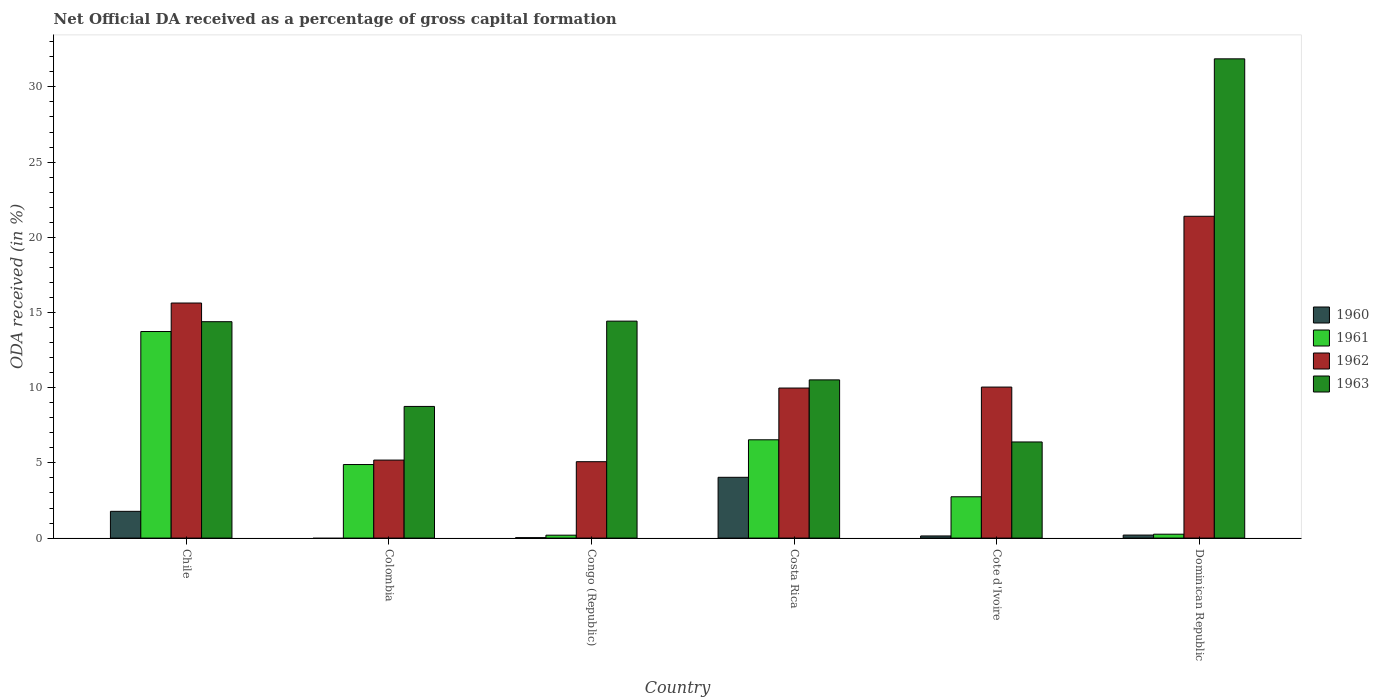How many different coloured bars are there?
Offer a terse response. 4. Are the number of bars on each tick of the X-axis equal?
Offer a terse response. No. What is the label of the 6th group of bars from the left?
Provide a succinct answer. Dominican Republic. In how many cases, is the number of bars for a given country not equal to the number of legend labels?
Give a very brief answer. 1. What is the net ODA received in 1960 in Dominican Republic?
Your answer should be very brief. 0.2. Across all countries, what is the maximum net ODA received in 1960?
Offer a terse response. 4.04. Across all countries, what is the minimum net ODA received in 1960?
Make the answer very short. 0. In which country was the net ODA received in 1961 maximum?
Your response must be concise. Chile. What is the total net ODA received in 1962 in the graph?
Provide a short and direct response. 67.31. What is the difference between the net ODA received in 1960 in Congo (Republic) and that in Dominican Republic?
Offer a very short reply. -0.17. What is the difference between the net ODA received in 1963 in Chile and the net ODA received in 1960 in Costa Rica?
Provide a short and direct response. 10.35. What is the average net ODA received in 1963 per country?
Offer a very short reply. 14.39. What is the difference between the net ODA received of/in 1961 and net ODA received of/in 1960 in Congo (Republic)?
Provide a succinct answer. 0.17. What is the ratio of the net ODA received in 1961 in Costa Rica to that in Cote d'Ivoire?
Give a very brief answer. 2.38. Is the difference between the net ODA received in 1961 in Chile and Cote d'Ivoire greater than the difference between the net ODA received in 1960 in Chile and Cote d'Ivoire?
Your response must be concise. Yes. What is the difference between the highest and the second highest net ODA received in 1962?
Offer a terse response. -11.35. What is the difference between the highest and the lowest net ODA received in 1962?
Your answer should be compact. 16.32. Is it the case that in every country, the sum of the net ODA received in 1963 and net ODA received in 1962 is greater than the sum of net ODA received in 1961 and net ODA received in 1960?
Offer a terse response. Yes. How many bars are there?
Offer a very short reply. 23. What is the difference between two consecutive major ticks on the Y-axis?
Offer a very short reply. 5. Are the values on the major ticks of Y-axis written in scientific E-notation?
Give a very brief answer. No. How many legend labels are there?
Your answer should be very brief. 4. How are the legend labels stacked?
Provide a succinct answer. Vertical. What is the title of the graph?
Your response must be concise. Net Official DA received as a percentage of gross capital formation. Does "1986" appear as one of the legend labels in the graph?
Provide a succinct answer. No. What is the label or title of the Y-axis?
Give a very brief answer. ODA received (in %). What is the ODA received (in %) in 1960 in Chile?
Your answer should be very brief. 1.78. What is the ODA received (in %) of 1961 in Chile?
Make the answer very short. 13.73. What is the ODA received (in %) in 1962 in Chile?
Give a very brief answer. 15.63. What is the ODA received (in %) of 1963 in Chile?
Provide a short and direct response. 14.39. What is the ODA received (in %) of 1961 in Colombia?
Give a very brief answer. 4.89. What is the ODA received (in %) in 1962 in Colombia?
Your response must be concise. 5.19. What is the ODA received (in %) of 1963 in Colombia?
Your answer should be very brief. 8.75. What is the ODA received (in %) in 1960 in Congo (Republic)?
Provide a succinct answer. 0.03. What is the ODA received (in %) of 1961 in Congo (Republic)?
Make the answer very short. 0.19. What is the ODA received (in %) of 1962 in Congo (Republic)?
Your answer should be compact. 5.08. What is the ODA received (in %) of 1963 in Congo (Republic)?
Your response must be concise. 14.43. What is the ODA received (in %) of 1960 in Costa Rica?
Provide a short and direct response. 4.04. What is the ODA received (in %) in 1961 in Costa Rica?
Offer a terse response. 6.54. What is the ODA received (in %) in 1962 in Costa Rica?
Give a very brief answer. 9.98. What is the ODA received (in %) of 1963 in Costa Rica?
Your response must be concise. 10.52. What is the ODA received (in %) in 1960 in Cote d'Ivoire?
Your answer should be very brief. 0.14. What is the ODA received (in %) of 1961 in Cote d'Ivoire?
Your answer should be very brief. 2.75. What is the ODA received (in %) in 1962 in Cote d'Ivoire?
Your answer should be very brief. 10.04. What is the ODA received (in %) in 1963 in Cote d'Ivoire?
Your answer should be compact. 6.39. What is the ODA received (in %) of 1960 in Dominican Republic?
Your answer should be compact. 0.2. What is the ODA received (in %) in 1961 in Dominican Republic?
Offer a terse response. 0.26. What is the ODA received (in %) in 1962 in Dominican Republic?
Keep it short and to the point. 21.4. What is the ODA received (in %) in 1963 in Dominican Republic?
Your answer should be compact. 31.86. Across all countries, what is the maximum ODA received (in %) of 1960?
Offer a terse response. 4.04. Across all countries, what is the maximum ODA received (in %) of 1961?
Offer a terse response. 13.73. Across all countries, what is the maximum ODA received (in %) of 1962?
Provide a short and direct response. 21.4. Across all countries, what is the maximum ODA received (in %) of 1963?
Provide a succinct answer. 31.86. Across all countries, what is the minimum ODA received (in %) in 1960?
Offer a very short reply. 0. Across all countries, what is the minimum ODA received (in %) in 1961?
Your answer should be very brief. 0.19. Across all countries, what is the minimum ODA received (in %) in 1962?
Make the answer very short. 5.08. Across all countries, what is the minimum ODA received (in %) of 1963?
Your answer should be very brief. 6.39. What is the total ODA received (in %) of 1960 in the graph?
Ensure brevity in your answer.  6.19. What is the total ODA received (in %) in 1961 in the graph?
Give a very brief answer. 28.36. What is the total ODA received (in %) in 1962 in the graph?
Provide a short and direct response. 67.31. What is the total ODA received (in %) in 1963 in the graph?
Provide a succinct answer. 86.34. What is the difference between the ODA received (in %) of 1961 in Chile and that in Colombia?
Offer a terse response. 8.84. What is the difference between the ODA received (in %) in 1962 in Chile and that in Colombia?
Your response must be concise. 10.44. What is the difference between the ODA received (in %) in 1963 in Chile and that in Colombia?
Ensure brevity in your answer.  5.63. What is the difference between the ODA received (in %) of 1960 in Chile and that in Congo (Republic)?
Offer a very short reply. 1.75. What is the difference between the ODA received (in %) in 1961 in Chile and that in Congo (Republic)?
Offer a terse response. 13.54. What is the difference between the ODA received (in %) of 1962 in Chile and that in Congo (Republic)?
Offer a terse response. 10.55. What is the difference between the ODA received (in %) of 1963 in Chile and that in Congo (Republic)?
Make the answer very short. -0.04. What is the difference between the ODA received (in %) of 1960 in Chile and that in Costa Rica?
Your response must be concise. -2.26. What is the difference between the ODA received (in %) of 1961 in Chile and that in Costa Rica?
Make the answer very short. 7.2. What is the difference between the ODA received (in %) in 1962 in Chile and that in Costa Rica?
Your answer should be very brief. 5.65. What is the difference between the ODA received (in %) of 1963 in Chile and that in Costa Rica?
Offer a very short reply. 3.87. What is the difference between the ODA received (in %) in 1960 in Chile and that in Cote d'Ivoire?
Offer a terse response. 1.64. What is the difference between the ODA received (in %) of 1961 in Chile and that in Cote d'Ivoire?
Provide a short and direct response. 10.99. What is the difference between the ODA received (in %) in 1962 in Chile and that in Cote d'Ivoire?
Your answer should be compact. 5.59. What is the difference between the ODA received (in %) of 1963 in Chile and that in Cote d'Ivoire?
Give a very brief answer. 8. What is the difference between the ODA received (in %) of 1960 in Chile and that in Dominican Republic?
Your answer should be compact. 1.58. What is the difference between the ODA received (in %) of 1961 in Chile and that in Dominican Republic?
Make the answer very short. 13.48. What is the difference between the ODA received (in %) of 1962 in Chile and that in Dominican Republic?
Your response must be concise. -5.77. What is the difference between the ODA received (in %) in 1963 in Chile and that in Dominican Republic?
Ensure brevity in your answer.  -17.48. What is the difference between the ODA received (in %) in 1961 in Colombia and that in Congo (Republic)?
Your response must be concise. 4.7. What is the difference between the ODA received (in %) of 1962 in Colombia and that in Congo (Republic)?
Make the answer very short. 0.11. What is the difference between the ODA received (in %) of 1963 in Colombia and that in Congo (Republic)?
Give a very brief answer. -5.67. What is the difference between the ODA received (in %) in 1961 in Colombia and that in Costa Rica?
Keep it short and to the point. -1.65. What is the difference between the ODA received (in %) in 1962 in Colombia and that in Costa Rica?
Offer a terse response. -4.79. What is the difference between the ODA received (in %) of 1963 in Colombia and that in Costa Rica?
Offer a very short reply. -1.76. What is the difference between the ODA received (in %) in 1961 in Colombia and that in Cote d'Ivoire?
Give a very brief answer. 2.14. What is the difference between the ODA received (in %) in 1962 in Colombia and that in Cote d'Ivoire?
Offer a terse response. -4.86. What is the difference between the ODA received (in %) in 1963 in Colombia and that in Cote d'Ivoire?
Your answer should be compact. 2.36. What is the difference between the ODA received (in %) of 1961 in Colombia and that in Dominican Republic?
Provide a succinct answer. 4.63. What is the difference between the ODA received (in %) of 1962 in Colombia and that in Dominican Republic?
Your answer should be compact. -16.21. What is the difference between the ODA received (in %) in 1963 in Colombia and that in Dominican Republic?
Provide a short and direct response. -23.11. What is the difference between the ODA received (in %) in 1960 in Congo (Republic) and that in Costa Rica?
Your answer should be very brief. -4.01. What is the difference between the ODA received (in %) in 1961 in Congo (Republic) and that in Costa Rica?
Give a very brief answer. -6.34. What is the difference between the ODA received (in %) in 1962 in Congo (Republic) and that in Costa Rica?
Make the answer very short. -4.9. What is the difference between the ODA received (in %) of 1963 in Congo (Republic) and that in Costa Rica?
Ensure brevity in your answer.  3.91. What is the difference between the ODA received (in %) in 1960 in Congo (Republic) and that in Cote d'Ivoire?
Offer a terse response. -0.11. What is the difference between the ODA received (in %) of 1961 in Congo (Republic) and that in Cote d'Ivoire?
Offer a very short reply. -2.55. What is the difference between the ODA received (in %) in 1962 in Congo (Republic) and that in Cote d'Ivoire?
Give a very brief answer. -4.96. What is the difference between the ODA received (in %) in 1963 in Congo (Republic) and that in Cote d'Ivoire?
Make the answer very short. 8.03. What is the difference between the ODA received (in %) in 1960 in Congo (Republic) and that in Dominican Republic?
Your answer should be very brief. -0.17. What is the difference between the ODA received (in %) of 1961 in Congo (Republic) and that in Dominican Republic?
Provide a short and direct response. -0.06. What is the difference between the ODA received (in %) in 1962 in Congo (Republic) and that in Dominican Republic?
Your response must be concise. -16.32. What is the difference between the ODA received (in %) of 1963 in Congo (Republic) and that in Dominican Republic?
Your response must be concise. -17.44. What is the difference between the ODA received (in %) in 1960 in Costa Rica and that in Cote d'Ivoire?
Give a very brief answer. 3.9. What is the difference between the ODA received (in %) in 1961 in Costa Rica and that in Cote d'Ivoire?
Make the answer very short. 3.79. What is the difference between the ODA received (in %) in 1962 in Costa Rica and that in Cote d'Ivoire?
Provide a succinct answer. -0.06. What is the difference between the ODA received (in %) in 1963 in Costa Rica and that in Cote d'Ivoire?
Give a very brief answer. 4.13. What is the difference between the ODA received (in %) of 1960 in Costa Rica and that in Dominican Republic?
Offer a terse response. 3.84. What is the difference between the ODA received (in %) in 1961 in Costa Rica and that in Dominican Republic?
Your answer should be compact. 6.28. What is the difference between the ODA received (in %) in 1962 in Costa Rica and that in Dominican Republic?
Provide a succinct answer. -11.42. What is the difference between the ODA received (in %) in 1963 in Costa Rica and that in Dominican Republic?
Provide a succinct answer. -21.35. What is the difference between the ODA received (in %) of 1960 in Cote d'Ivoire and that in Dominican Republic?
Your answer should be very brief. -0.06. What is the difference between the ODA received (in %) of 1961 in Cote d'Ivoire and that in Dominican Republic?
Make the answer very short. 2.49. What is the difference between the ODA received (in %) in 1962 in Cote d'Ivoire and that in Dominican Republic?
Provide a succinct answer. -11.35. What is the difference between the ODA received (in %) of 1963 in Cote d'Ivoire and that in Dominican Republic?
Offer a very short reply. -25.47. What is the difference between the ODA received (in %) of 1960 in Chile and the ODA received (in %) of 1961 in Colombia?
Keep it short and to the point. -3.11. What is the difference between the ODA received (in %) in 1960 in Chile and the ODA received (in %) in 1962 in Colombia?
Make the answer very short. -3.41. What is the difference between the ODA received (in %) of 1960 in Chile and the ODA received (in %) of 1963 in Colombia?
Your answer should be very brief. -6.97. What is the difference between the ODA received (in %) of 1961 in Chile and the ODA received (in %) of 1962 in Colombia?
Give a very brief answer. 8.55. What is the difference between the ODA received (in %) of 1961 in Chile and the ODA received (in %) of 1963 in Colombia?
Provide a short and direct response. 4.98. What is the difference between the ODA received (in %) in 1962 in Chile and the ODA received (in %) in 1963 in Colombia?
Provide a short and direct response. 6.88. What is the difference between the ODA received (in %) in 1960 in Chile and the ODA received (in %) in 1961 in Congo (Republic)?
Your response must be concise. 1.59. What is the difference between the ODA received (in %) of 1960 in Chile and the ODA received (in %) of 1962 in Congo (Republic)?
Ensure brevity in your answer.  -3.3. What is the difference between the ODA received (in %) in 1960 in Chile and the ODA received (in %) in 1963 in Congo (Republic)?
Ensure brevity in your answer.  -12.65. What is the difference between the ODA received (in %) of 1961 in Chile and the ODA received (in %) of 1962 in Congo (Republic)?
Provide a short and direct response. 8.66. What is the difference between the ODA received (in %) of 1961 in Chile and the ODA received (in %) of 1963 in Congo (Republic)?
Provide a short and direct response. -0.69. What is the difference between the ODA received (in %) in 1962 in Chile and the ODA received (in %) in 1963 in Congo (Republic)?
Your response must be concise. 1.2. What is the difference between the ODA received (in %) in 1960 in Chile and the ODA received (in %) in 1961 in Costa Rica?
Make the answer very short. -4.76. What is the difference between the ODA received (in %) in 1960 in Chile and the ODA received (in %) in 1962 in Costa Rica?
Offer a very short reply. -8.2. What is the difference between the ODA received (in %) in 1960 in Chile and the ODA received (in %) in 1963 in Costa Rica?
Provide a succinct answer. -8.74. What is the difference between the ODA received (in %) of 1961 in Chile and the ODA received (in %) of 1962 in Costa Rica?
Provide a succinct answer. 3.76. What is the difference between the ODA received (in %) of 1961 in Chile and the ODA received (in %) of 1963 in Costa Rica?
Make the answer very short. 3.22. What is the difference between the ODA received (in %) of 1962 in Chile and the ODA received (in %) of 1963 in Costa Rica?
Keep it short and to the point. 5.11. What is the difference between the ODA received (in %) of 1960 in Chile and the ODA received (in %) of 1961 in Cote d'Ivoire?
Your answer should be very brief. -0.97. What is the difference between the ODA received (in %) in 1960 in Chile and the ODA received (in %) in 1962 in Cote d'Ivoire?
Offer a terse response. -8.26. What is the difference between the ODA received (in %) of 1960 in Chile and the ODA received (in %) of 1963 in Cote d'Ivoire?
Keep it short and to the point. -4.61. What is the difference between the ODA received (in %) of 1961 in Chile and the ODA received (in %) of 1962 in Cote d'Ivoire?
Give a very brief answer. 3.69. What is the difference between the ODA received (in %) in 1961 in Chile and the ODA received (in %) in 1963 in Cote d'Ivoire?
Provide a short and direct response. 7.34. What is the difference between the ODA received (in %) of 1962 in Chile and the ODA received (in %) of 1963 in Cote d'Ivoire?
Your answer should be very brief. 9.24. What is the difference between the ODA received (in %) in 1960 in Chile and the ODA received (in %) in 1961 in Dominican Republic?
Provide a short and direct response. 1.52. What is the difference between the ODA received (in %) in 1960 in Chile and the ODA received (in %) in 1962 in Dominican Republic?
Provide a succinct answer. -19.62. What is the difference between the ODA received (in %) of 1960 in Chile and the ODA received (in %) of 1963 in Dominican Republic?
Your answer should be compact. -30.09. What is the difference between the ODA received (in %) of 1961 in Chile and the ODA received (in %) of 1962 in Dominican Republic?
Ensure brevity in your answer.  -7.66. What is the difference between the ODA received (in %) in 1961 in Chile and the ODA received (in %) in 1963 in Dominican Republic?
Offer a very short reply. -18.13. What is the difference between the ODA received (in %) in 1962 in Chile and the ODA received (in %) in 1963 in Dominican Republic?
Ensure brevity in your answer.  -16.24. What is the difference between the ODA received (in %) of 1961 in Colombia and the ODA received (in %) of 1962 in Congo (Republic)?
Your answer should be very brief. -0.19. What is the difference between the ODA received (in %) of 1961 in Colombia and the ODA received (in %) of 1963 in Congo (Republic)?
Provide a short and direct response. -9.54. What is the difference between the ODA received (in %) of 1962 in Colombia and the ODA received (in %) of 1963 in Congo (Republic)?
Provide a succinct answer. -9.24. What is the difference between the ODA received (in %) in 1961 in Colombia and the ODA received (in %) in 1962 in Costa Rica?
Provide a short and direct response. -5.09. What is the difference between the ODA received (in %) of 1961 in Colombia and the ODA received (in %) of 1963 in Costa Rica?
Provide a succinct answer. -5.63. What is the difference between the ODA received (in %) in 1962 in Colombia and the ODA received (in %) in 1963 in Costa Rica?
Keep it short and to the point. -5.33. What is the difference between the ODA received (in %) in 1961 in Colombia and the ODA received (in %) in 1962 in Cote d'Ivoire?
Provide a succinct answer. -5.15. What is the difference between the ODA received (in %) of 1961 in Colombia and the ODA received (in %) of 1963 in Cote d'Ivoire?
Provide a succinct answer. -1.5. What is the difference between the ODA received (in %) in 1962 in Colombia and the ODA received (in %) in 1963 in Cote d'Ivoire?
Ensure brevity in your answer.  -1.2. What is the difference between the ODA received (in %) in 1961 in Colombia and the ODA received (in %) in 1962 in Dominican Republic?
Your answer should be very brief. -16.51. What is the difference between the ODA received (in %) in 1961 in Colombia and the ODA received (in %) in 1963 in Dominican Republic?
Ensure brevity in your answer.  -26.97. What is the difference between the ODA received (in %) in 1962 in Colombia and the ODA received (in %) in 1963 in Dominican Republic?
Your response must be concise. -26.68. What is the difference between the ODA received (in %) of 1960 in Congo (Republic) and the ODA received (in %) of 1961 in Costa Rica?
Make the answer very short. -6.51. What is the difference between the ODA received (in %) of 1960 in Congo (Republic) and the ODA received (in %) of 1962 in Costa Rica?
Provide a succinct answer. -9.95. What is the difference between the ODA received (in %) of 1960 in Congo (Republic) and the ODA received (in %) of 1963 in Costa Rica?
Provide a short and direct response. -10.49. What is the difference between the ODA received (in %) of 1961 in Congo (Republic) and the ODA received (in %) of 1962 in Costa Rica?
Give a very brief answer. -9.78. What is the difference between the ODA received (in %) in 1961 in Congo (Republic) and the ODA received (in %) in 1963 in Costa Rica?
Offer a terse response. -10.32. What is the difference between the ODA received (in %) in 1962 in Congo (Republic) and the ODA received (in %) in 1963 in Costa Rica?
Provide a short and direct response. -5.44. What is the difference between the ODA received (in %) in 1960 in Congo (Republic) and the ODA received (in %) in 1961 in Cote d'Ivoire?
Provide a short and direct response. -2.72. What is the difference between the ODA received (in %) in 1960 in Congo (Republic) and the ODA received (in %) in 1962 in Cote d'Ivoire?
Ensure brevity in your answer.  -10.01. What is the difference between the ODA received (in %) of 1960 in Congo (Republic) and the ODA received (in %) of 1963 in Cote d'Ivoire?
Your response must be concise. -6.36. What is the difference between the ODA received (in %) in 1961 in Congo (Republic) and the ODA received (in %) in 1962 in Cote d'Ivoire?
Keep it short and to the point. -9.85. What is the difference between the ODA received (in %) of 1961 in Congo (Republic) and the ODA received (in %) of 1963 in Cote d'Ivoire?
Provide a succinct answer. -6.2. What is the difference between the ODA received (in %) in 1962 in Congo (Republic) and the ODA received (in %) in 1963 in Cote d'Ivoire?
Give a very brief answer. -1.31. What is the difference between the ODA received (in %) of 1960 in Congo (Republic) and the ODA received (in %) of 1961 in Dominican Republic?
Keep it short and to the point. -0.23. What is the difference between the ODA received (in %) of 1960 in Congo (Republic) and the ODA received (in %) of 1962 in Dominican Republic?
Offer a terse response. -21.37. What is the difference between the ODA received (in %) of 1960 in Congo (Republic) and the ODA received (in %) of 1963 in Dominican Republic?
Provide a short and direct response. -31.84. What is the difference between the ODA received (in %) of 1961 in Congo (Republic) and the ODA received (in %) of 1962 in Dominican Republic?
Offer a very short reply. -21.2. What is the difference between the ODA received (in %) of 1961 in Congo (Republic) and the ODA received (in %) of 1963 in Dominican Republic?
Give a very brief answer. -31.67. What is the difference between the ODA received (in %) of 1962 in Congo (Republic) and the ODA received (in %) of 1963 in Dominican Republic?
Make the answer very short. -26.79. What is the difference between the ODA received (in %) of 1960 in Costa Rica and the ODA received (in %) of 1961 in Cote d'Ivoire?
Offer a terse response. 1.29. What is the difference between the ODA received (in %) of 1960 in Costa Rica and the ODA received (in %) of 1962 in Cote d'Ivoire?
Make the answer very short. -6. What is the difference between the ODA received (in %) of 1960 in Costa Rica and the ODA received (in %) of 1963 in Cote d'Ivoire?
Your answer should be very brief. -2.35. What is the difference between the ODA received (in %) in 1961 in Costa Rica and the ODA received (in %) in 1962 in Cote d'Ivoire?
Offer a very short reply. -3.51. What is the difference between the ODA received (in %) in 1961 in Costa Rica and the ODA received (in %) in 1963 in Cote d'Ivoire?
Give a very brief answer. 0.14. What is the difference between the ODA received (in %) of 1962 in Costa Rica and the ODA received (in %) of 1963 in Cote d'Ivoire?
Offer a very short reply. 3.59. What is the difference between the ODA received (in %) in 1960 in Costa Rica and the ODA received (in %) in 1961 in Dominican Republic?
Provide a short and direct response. 3.78. What is the difference between the ODA received (in %) of 1960 in Costa Rica and the ODA received (in %) of 1962 in Dominican Republic?
Provide a short and direct response. -17.35. What is the difference between the ODA received (in %) in 1960 in Costa Rica and the ODA received (in %) in 1963 in Dominican Republic?
Offer a terse response. -27.82. What is the difference between the ODA received (in %) of 1961 in Costa Rica and the ODA received (in %) of 1962 in Dominican Republic?
Keep it short and to the point. -14.86. What is the difference between the ODA received (in %) of 1961 in Costa Rica and the ODA received (in %) of 1963 in Dominican Republic?
Provide a succinct answer. -25.33. What is the difference between the ODA received (in %) of 1962 in Costa Rica and the ODA received (in %) of 1963 in Dominican Republic?
Provide a short and direct response. -21.89. What is the difference between the ODA received (in %) of 1960 in Cote d'Ivoire and the ODA received (in %) of 1961 in Dominican Republic?
Keep it short and to the point. -0.12. What is the difference between the ODA received (in %) of 1960 in Cote d'Ivoire and the ODA received (in %) of 1962 in Dominican Republic?
Ensure brevity in your answer.  -21.25. What is the difference between the ODA received (in %) in 1960 in Cote d'Ivoire and the ODA received (in %) in 1963 in Dominican Republic?
Make the answer very short. -31.72. What is the difference between the ODA received (in %) in 1961 in Cote d'Ivoire and the ODA received (in %) in 1962 in Dominican Republic?
Your answer should be compact. -18.65. What is the difference between the ODA received (in %) in 1961 in Cote d'Ivoire and the ODA received (in %) in 1963 in Dominican Republic?
Offer a very short reply. -29.12. What is the difference between the ODA received (in %) of 1962 in Cote d'Ivoire and the ODA received (in %) of 1963 in Dominican Republic?
Your answer should be compact. -21.82. What is the average ODA received (in %) of 1960 per country?
Make the answer very short. 1.03. What is the average ODA received (in %) in 1961 per country?
Give a very brief answer. 4.73. What is the average ODA received (in %) of 1962 per country?
Your response must be concise. 11.22. What is the average ODA received (in %) of 1963 per country?
Give a very brief answer. 14.39. What is the difference between the ODA received (in %) of 1960 and ODA received (in %) of 1961 in Chile?
Your answer should be very brief. -11.96. What is the difference between the ODA received (in %) in 1960 and ODA received (in %) in 1962 in Chile?
Your response must be concise. -13.85. What is the difference between the ODA received (in %) of 1960 and ODA received (in %) of 1963 in Chile?
Offer a terse response. -12.61. What is the difference between the ODA received (in %) of 1961 and ODA received (in %) of 1962 in Chile?
Give a very brief answer. -1.89. What is the difference between the ODA received (in %) of 1961 and ODA received (in %) of 1963 in Chile?
Ensure brevity in your answer.  -0.65. What is the difference between the ODA received (in %) of 1962 and ODA received (in %) of 1963 in Chile?
Your answer should be compact. 1.24. What is the difference between the ODA received (in %) of 1961 and ODA received (in %) of 1962 in Colombia?
Ensure brevity in your answer.  -0.3. What is the difference between the ODA received (in %) in 1961 and ODA received (in %) in 1963 in Colombia?
Your response must be concise. -3.86. What is the difference between the ODA received (in %) of 1962 and ODA received (in %) of 1963 in Colombia?
Make the answer very short. -3.57. What is the difference between the ODA received (in %) in 1960 and ODA received (in %) in 1961 in Congo (Republic)?
Make the answer very short. -0.17. What is the difference between the ODA received (in %) in 1960 and ODA received (in %) in 1962 in Congo (Republic)?
Make the answer very short. -5.05. What is the difference between the ODA received (in %) of 1960 and ODA received (in %) of 1963 in Congo (Republic)?
Make the answer very short. -14.4. What is the difference between the ODA received (in %) of 1961 and ODA received (in %) of 1962 in Congo (Republic)?
Your response must be concise. -4.89. What is the difference between the ODA received (in %) of 1961 and ODA received (in %) of 1963 in Congo (Republic)?
Provide a short and direct response. -14.23. What is the difference between the ODA received (in %) of 1962 and ODA received (in %) of 1963 in Congo (Republic)?
Provide a succinct answer. -9.35. What is the difference between the ODA received (in %) of 1960 and ODA received (in %) of 1961 in Costa Rica?
Your answer should be very brief. -2.49. What is the difference between the ODA received (in %) in 1960 and ODA received (in %) in 1962 in Costa Rica?
Give a very brief answer. -5.93. What is the difference between the ODA received (in %) of 1960 and ODA received (in %) of 1963 in Costa Rica?
Your answer should be compact. -6.48. What is the difference between the ODA received (in %) in 1961 and ODA received (in %) in 1962 in Costa Rica?
Your response must be concise. -3.44. What is the difference between the ODA received (in %) of 1961 and ODA received (in %) of 1963 in Costa Rica?
Make the answer very short. -3.98. What is the difference between the ODA received (in %) of 1962 and ODA received (in %) of 1963 in Costa Rica?
Ensure brevity in your answer.  -0.54. What is the difference between the ODA received (in %) in 1960 and ODA received (in %) in 1961 in Cote d'Ivoire?
Your response must be concise. -2.6. What is the difference between the ODA received (in %) of 1960 and ODA received (in %) of 1962 in Cote d'Ivoire?
Your answer should be compact. -9.9. What is the difference between the ODA received (in %) of 1960 and ODA received (in %) of 1963 in Cote d'Ivoire?
Offer a very short reply. -6.25. What is the difference between the ODA received (in %) of 1961 and ODA received (in %) of 1962 in Cote d'Ivoire?
Keep it short and to the point. -7.29. What is the difference between the ODA received (in %) of 1961 and ODA received (in %) of 1963 in Cote d'Ivoire?
Make the answer very short. -3.64. What is the difference between the ODA received (in %) of 1962 and ODA received (in %) of 1963 in Cote d'Ivoire?
Provide a succinct answer. 3.65. What is the difference between the ODA received (in %) of 1960 and ODA received (in %) of 1961 in Dominican Republic?
Offer a terse response. -0.06. What is the difference between the ODA received (in %) in 1960 and ODA received (in %) in 1962 in Dominican Republic?
Offer a terse response. -21.2. What is the difference between the ODA received (in %) of 1960 and ODA received (in %) of 1963 in Dominican Republic?
Keep it short and to the point. -31.66. What is the difference between the ODA received (in %) of 1961 and ODA received (in %) of 1962 in Dominican Republic?
Your answer should be compact. -21.14. What is the difference between the ODA received (in %) in 1961 and ODA received (in %) in 1963 in Dominican Republic?
Offer a very short reply. -31.61. What is the difference between the ODA received (in %) of 1962 and ODA received (in %) of 1963 in Dominican Republic?
Your answer should be very brief. -10.47. What is the ratio of the ODA received (in %) of 1961 in Chile to that in Colombia?
Make the answer very short. 2.81. What is the ratio of the ODA received (in %) in 1962 in Chile to that in Colombia?
Your answer should be compact. 3.01. What is the ratio of the ODA received (in %) in 1963 in Chile to that in Colombia?
Provide a succinct answer. 1.64. What is the ratio of the ODA received (in %) of 1960 in Chile to that in Congo (Republic)?
Keep it short and to the point. 62.32. What is the ratio of the ODA received (in %) of 1961 in Chile to that in Congo (Republic)?
Provide a short and direct response. 70.89. What is the ratio of the ODA received (in %) in 1962 in Chile to that in Congo (Republic)?
Give a very brief answer. 3.08. What is the ratio of the ODA received (in %) of 1960 in Chile to that in Costa Rica?
Offer a terse response. 0.44. What is the ratio of the ODA received (in %) of 1961 in Chile to that in Costa Rica?
Your response must be concise. 2.1. What is the ratio of the ODA received (in %) in 1962 in Chile to that in Costa Rica?
Your response must be concise. 1.57. What is the ratio of the ODA received (in %) of 1963 in Chile to that in Costa Rica?
Your answer should be very brief. 1.37. What is the ratio of the ODA received (in %) of 1960 in Chile to that in Cote d'Ivoire?
Your response must be concise. 12.5. What is the ratio of the ODA received (in %) of 1961 in Chile to that in Cote d'Ivoire?
Ensure brevity in your answer.  5. What is the ratio of the ODA received (in %) in 1962 in Chile to that in Cote d'Ivoire?
Ensure brevity in your answer.  1.56. What is the ratio of the ODA received (in %) in 1963 in Chile to that in Cote d'Ivoire?
Provide a short and direct response. 2.25. What is the ratio of the ODA received (in %) in 1960 in Chile to that in Dominican Republic?
Offer a very short reply. 8.87. What is the ratio of the ODA received (in %) in 1961 in Chile to that in Dominican Republic?
Offer a very short reply. 53.11. What is the ratio of the ODA received (in %) in 1962 in Chile to that in Dominican Republic?
Keep it short and to the point. 0.73. What is the ratio of the ODA received (in %) of 1963 in Chile to that in Dominican Republic?
Your answer should be very brief. 0.45. What is the ratio of the ODA received (in %) of 1961 in Colombia to that in Congo (Republic)?
Offer a very short reply. 25.24. What is the ratio of the ODA received (in %) in 1962 in Colombia to that in Congo (Republic)?
Keep it short and to the point. 1.02. What is the ratio of the ODA received (in %) of 1963 in Colombia to that in Congo (Republic)?
Your answer should be compact. 0.61. What is the ratio of the ODA received (in %) in 1961 in Colombia to that in Costa Rica?
Offer a terse response. 0.75. What is the ratio of the ODA received (in %) in 1962 in Colombia to that in Costa Rica?
Your answer should be compact. 0.52. What is the ratio of the ODA received (in %) of 1963 in Colombia to that in Costa Rica?
Provide a short and direct response. 0.83. What is the ratio of the ODA received (in %) of 1961 in Colombia to that in Cote d'Ivoire?
Provide a succinct answer. 1.78. What is the ratio of the ODA received (in %) in 1962 in Colombia to that in Cote d'Ivoire?
Provide a short and direct response. 0.52. What is the ratio of the ODA received (in %) of 1963 in Colombia to that in Cote d'Ivoire?
Your answer should be compact. 1.37. What is the ratio of the ODA received (in %) of 1961 in Colombia to that in Dominican Republic?
Provide a short and direct response. 18.91. What is the ratio of the ODA received (in %) in 1962 in Colombia to that in Dominican Republic?
Your answer should be compact. 0.24. What is the ratio of the ODA received (in %) of 1963 in Colombia to that in Dominican Republic?
Your answer should be compact. 0.27. What is the ratio of the ODA received (in %) of 1960 in Congo (Republic) to that in Costa Rica?
Provide a short and direct response. 0.01. What is the ratio of the ODA received (in %) of 1961 in Congo (Republic) to that in Costa Rica?
Provide a short and direct response. 0.03. What is the ratio of the ODA received (in %) in 1962 in Congo (Republic) to that in Costa Rica?
Your answer should be very brief. 0.51. What is the ratio of the ODA received (in %) of 1963 in Congo (Republic) to that in Costa Rica?
Your answer should be compact. 1.37. What is the ratio of the ODA received (in %) of 1960 in Congo (Republic) to that in Cote d'Ivoire?
Offer a very short reply. 0.2. What is the ratio of the ODA received (in %) of 1961 in Congo (Republic) to that in Cote d'Ivoire?
Provide a short and direct response. 0.07. What is the ratio of the ODA received (in %) of 1962 in Congo (Republic) to that in Cote d'Ivoire?
Provide a succinct answer. 0.51. What is the ratio of the ODA received (in %) of 1963 in Congo (Republic) to that in Cote d'Ivoire?
Your answer should be compact. 2.26. What is the ratio of the ODA received (in %) in 1960 in Congo (Republic) to that in Dominican Republic?
Offer a terse response. 0.14. What is the ratio of the ODA received (in %) of 1961 in Congo (Republic) to that in Dominican Republic?
Provide a short and direct response. 0.75. What is the ratio of the ODA received (in %) of 1962 in Congo (Republic) to that in Dominican Republic?
Give a very brief answer. 0.24. What is the ratio of the ODA received (in %) in 1963 in Congo (Republic) to that in Dominican Republic?
Your answer should be very brief. 0.45. What is the ratio of the ODA received (in %) in 1960 in Costa Rica to that in Cote d'Ivoire?
Your answer should be compact. 28.4. What is the ratio of the ODA received (in %) in 1961 in Costa Rica to that in Cote d'Ivoire?
Keep it short and to the point. 2.38. What is the ratio of the ODA received (in %) in 1962 in Costa Rica to that in Cote d'Ivoire?
Provide a short and direct response. 0.99. What is the ratio of the ODA received (in %) in 1963 in Costa Rica to that in Cote d'Ivoire?
Your response must be concise. 1.65. What is the ratio of the ODA received (in %) of 1960 in Costa Rica to that in Dominican Republic?
Ensure brevity in your answer.  20.16. What is the ratio of the ODA received (in %) in 1961 in Costa Rica to that in Dominican Republic?
Provide a succinct answer. 25.27. What is the ratio of the ODA received (in %) in 1962 in Costa Rica to that in Dominican Republic?
Provide a succinct answer. 0.47. What is the ratio of the ODA received (in %) in 1963 in Costa Rica to that in Dominican Republic?
Make the answer very short. 0.33. What is the ratio of the ODA received (in %) of 1960 in Cote d'Ivoire to that in Dominican Republic?
Your answer should be very brief. 0.71. What is the ratio of the ODA received (in %) of 1961 in Cote d'Ivoire to that in Dominican Republic?
Keep it short and to the point. 10.62. What is the ratio of the ODA received (in %) of 1962 in Cote d'Ivoire to that in Dominican Republic?
Ensure brevity in your answer.  0.47. What is the ratio of the ODA received (in %) in 1963 in Cote d'Ivoire to that in Dominican Republic?
Offer a terse response. 0.2. What is the difference between the highest and the second highest ODA received (in %) in 1960?
Give a very brief answer. 2.26. What is the difference between the highest and the second highest ODA received (in %) of 1961?
Ensure brevity in your answer.  7.2. What is the difference between the highest and the second highest ODA received (in %) of 1962?
Your response must be concise. 5.77. What is the difference between the highest and the second highest ODA received (in %) of 1963?
Provide a short and direct response. 17.44. What is the difference between the highest and the lowest ODA received (in %) in 1960?
Give a very brief answer. 4.04. What is the difference between the highest and the lowest ODA received (in %) in 1961?
Provide a succinct answer. 13.54. What is the difference between the highest and the lowest ODA received (in %) of 1962?
Make the answer very short. 16.32. What is the difference between the highest and the lowest ODA received (in %) in 1963?
Give a very brief answer. 25.47. 